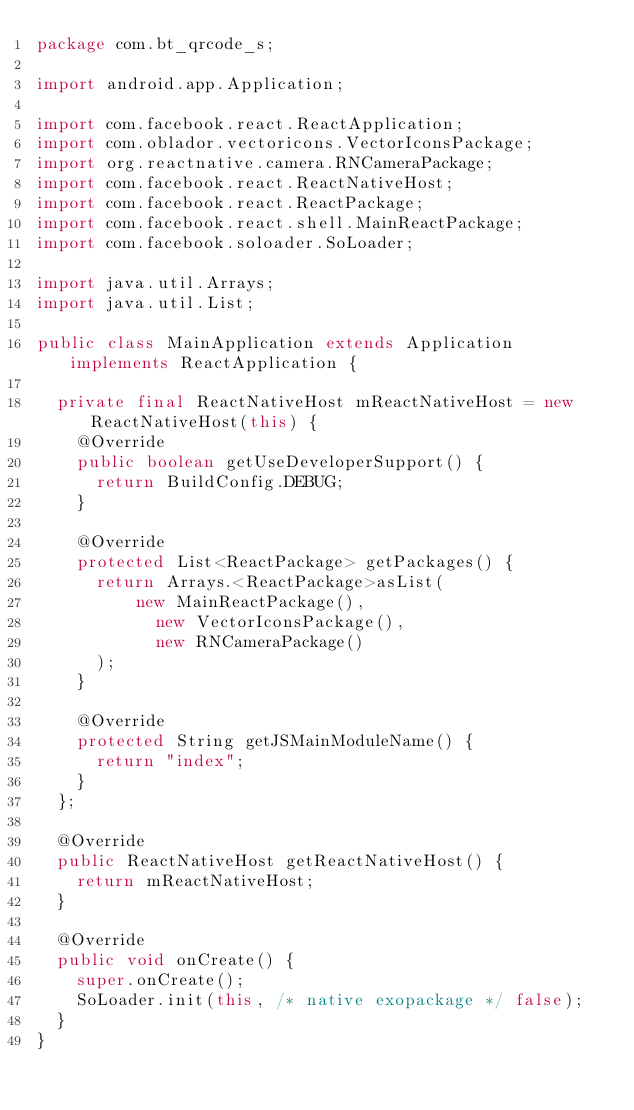<code> <loc_0><loc_0><loc_500><loc_500><_Java_>package com.bt_qrcode_s;

import android.app.Application;

import com.facebook.react.ReactApplication;
import com.oblador.vectoricons.VectorIconsPackage;
import org.reactnative.camera.RNCameraPackage;
import com.facebook.react.ReactNativeHost;
import com.facebook.react.ReactPackage;
import com.facebook.react.shell.MainReactPackage;
import com.facebook.soloader.SoLoader;

import java.util.Arrays;
import java.util.List;

public class MainApplication extends Application implements ReactApplication {

  private final ReactNativeHost mReactNativeHost = new ReactNativeHost(this) {
    @Override
    public boolean getUseDeveloperSupport() {
      return BuildConfig.DEBUG;
    }

    @Override
    protected List<ReactPackage> getPackages() {
      return Arrays.<ReactPackage>asList(
          new MainReactPackage(),
            new VectorIconsPackage(),
            new RNCameraPackage()
      );
    }

    @Override
    protected String getJSMainModuleName() {
      return "index";
    }
  };

  @Override
  public ReactNativeHost getReactNativeHost() {
    return mReactNativeHost;
  }

  @Override
  public void onCreate() {
    super.onCreate();
    SoLoader.init(this, /* native exopackage */ false);
  }
}
</code> 